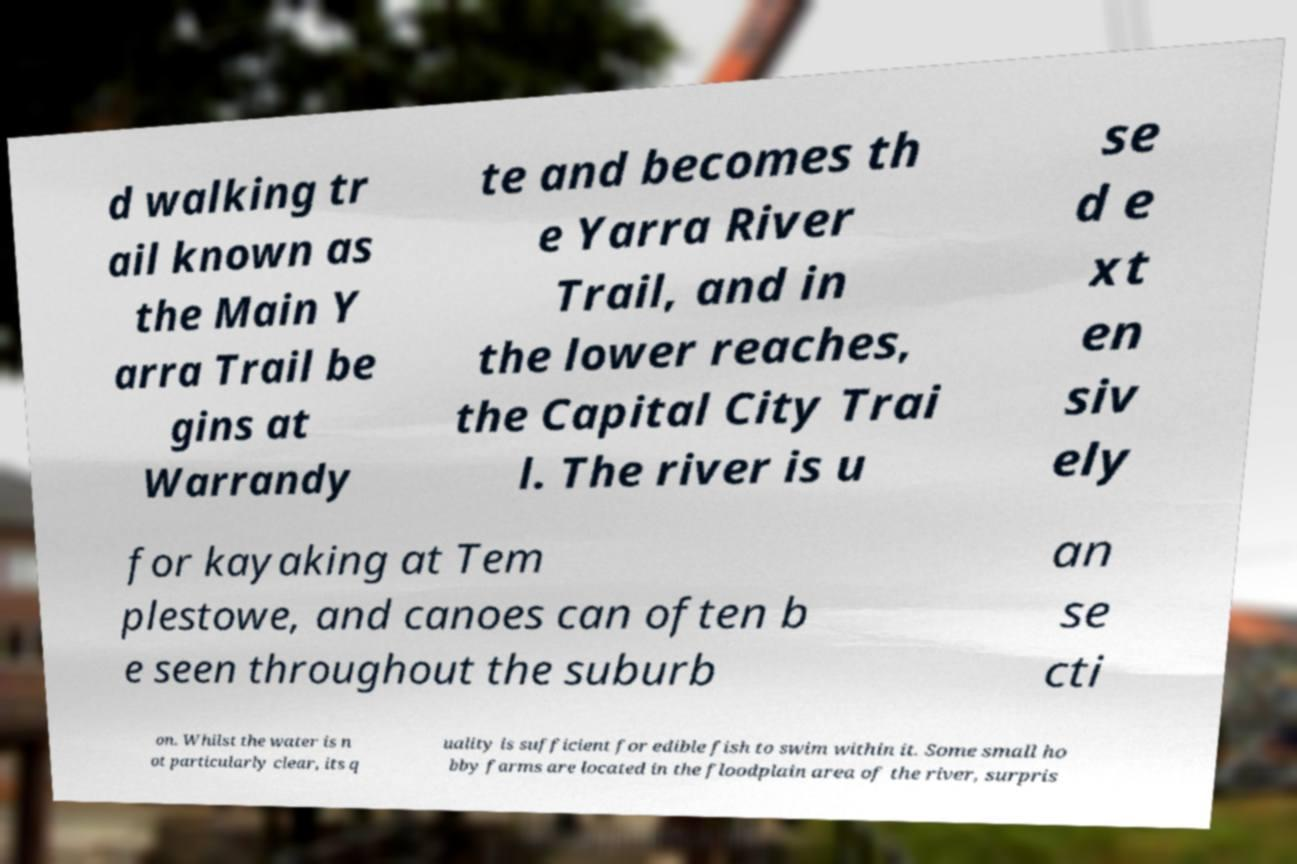Can you read and provide the text displayed in the image?This photo seems to have some interesting text. Can you extract and type it out for me? d walking tr ail known as the Main Y arra Trail be gins at Warrandy te and becomes th e Yarra River Trail, and in the lower reaches, the Capital City Trai l. The river is u se d e xt en siv ely for kayaking at Tem plestowe, and canoes can often b e seen throughout the suburb an se cti on. Whilst the water is n ot particularly clear, its q uality is sufficient for edible fish to swim within it. Some small ho bby farms are located in the floodplain area of the river, surpris 